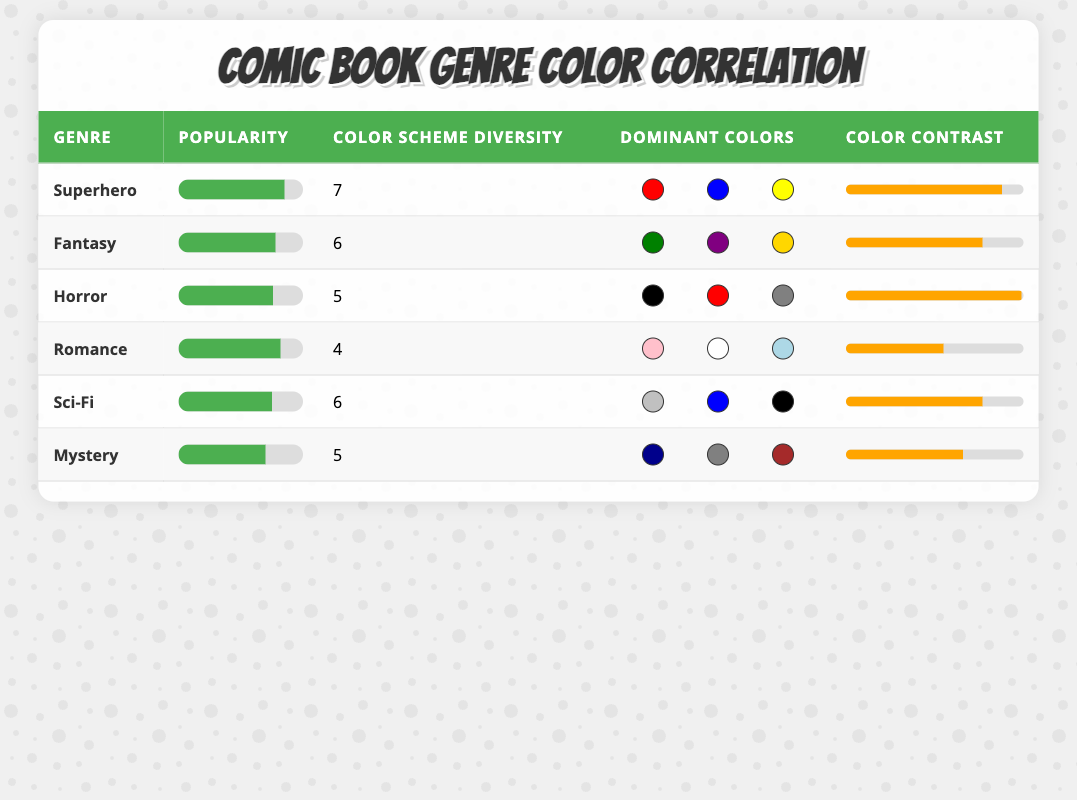What's the average popularity score for the genres listed? To find the average popularity score, add all the scores together: 85 + 78 + 76 + 82 + 75 + 70 = 466. There are 6 genres, so the average is 466 / 6 = 77.67.
Answer: 77.67 Which comic genre has the highest color scheme diversity? Checking the 'Color Scheme Diversity' column, Superhero has the highest value of 7.
Answer: Superhero Is the dominant color scheme in Romance primarily warm colors? The dominant colors in Romance are pink, white, and light blue, which are all generally considered warm (with the exception of light blue, which is cooler but still soft). Thus, it can be classified mostly as warm colors.
Answer: Yes Which genre has the lowest color contrast score? Looking at the 'Color Contrast' column, Mystery has the lowest score of 66%.
Answer: Mystery What is the difference in popularity score between the Superhero and Horror genres? The popularity score for Superhero is 85, and for Horror, it is 76. The difference is 85 - 76 = 9.
Answer: 9 Is there a correlation between color scheme diversity and average popularity score? Analyzing the data, we see that Superhero (7) is highest in diversity and popularity (85), while Mystery (5) is lowest in both. However, it's not a direct correlation as other genres with lower diversity still have high popularity. Thus, a definitive correlation cannot be established with the current data set.
Answer: No What is the total color scheme diversity score of all genres combined? Adding the color scheme diversity scores for all genres gives us 7 + 6 + 5 + 4 + 6 + 5 = 33.
Answer: 33 Which genre has a dominant color scheme that includes black? Checking the 'Dominant Colors' column, Horror and Sci-Fi both list black as a dominant color.
Answer: Horror and Sci-Fi What percentage of color scheme diversity does the Fantasy genre have compared to the most diverse genre? Fantasy has a color scheme diversity of 6 and Superhero has the highest at 7. To find the percentage: (6 / 7) * 100 = 85.71%.
Answer: 85.71% 